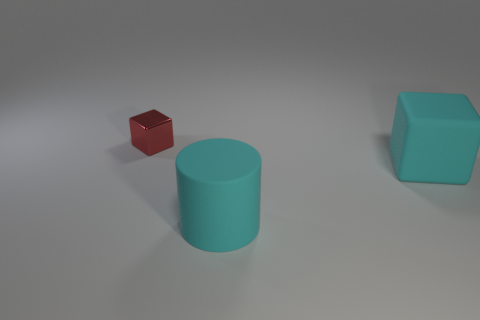Do the cyan cube and the red metallic cube have the same size?
Your answer should be very brief. No. There is a matte object that is the same color as the cylinder; what is its size?
Ensure brevity in your answer.  Large. Is the size of the block that is right of the red object the same as the red metallic cube on the left side of the large rubber cylinder?
Offer a very short reply. No. What is the shape of the small object?
Your response must be concise. Cube. Is there anything else that has the same material as the cyan block?
Your response must be concise. Yes. There is a rubber thing that is in front of the cube on the right side of the tiny thing; how big is it?
Offer a terse response. Large. Are there the same number of tiny shiny things that are to the right of the matte cylinder and tiny yellow matte cubes?
Your response must be concise. Yes. What number of other objects are there of the same color as the large matte cube?
Ensure brevity in your answer.  1. Are there fewer small red metal blocks that are right of the cyan cylinder than rubber blocks?
Your answer should be very brief. Yes. Are there any cubes that have the same size as the cyan cylinder?
Your response must be concise. Yes. 